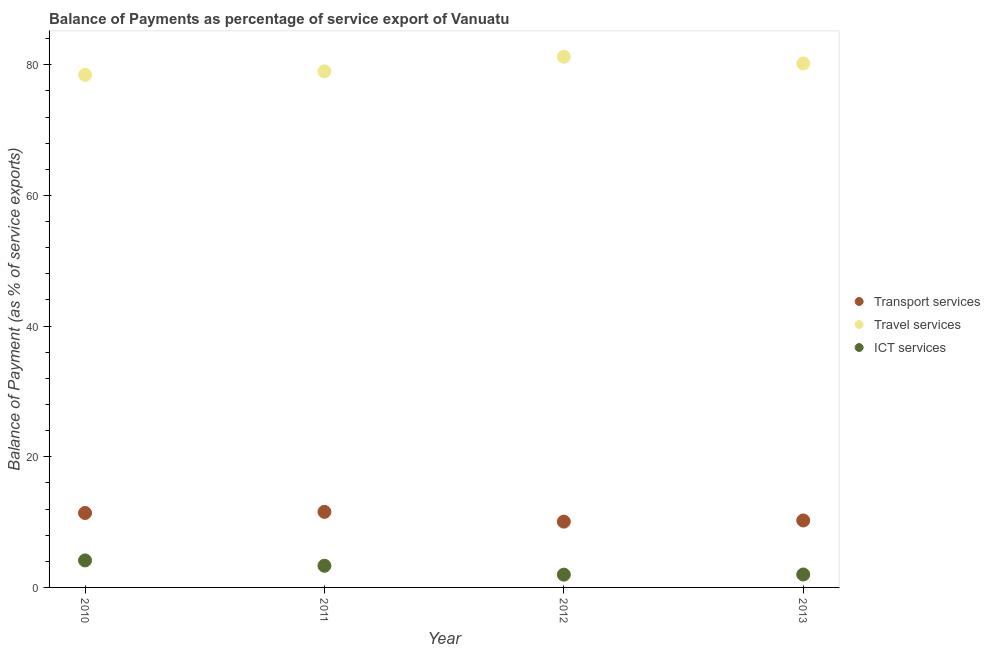Is the number of dotlines equal to the number of legend labels?
Give a very brief answer. Yes. What is the balance of payment of travel services in 2011?
Ensure brevity in your answer.  78.99. Across all years, what is the maximum balance of payment of ict services?
Offer a very short reply. 4.13. Across all years, what is the minimum balance of payment of transport services?
Your answer should be compact. 10.07. In which year was the balance of payment of transport services maximum?
Your answer should be very brief. 2011. What is the total balance of payment of ict services in the graph?
Your response must be concise. 11.38. What is the difference between the balance of payment of travel services in 2011 and that in 2012?
Give a very brief answer. -2.23. What is the difference between the balance of payment of transport services in 2011 and the balance of payment of ict services in 2010?
Offer a very short reply. 7.43. What is the average balance of payment of travel services per year?
Give a very brief answer. 79.72. In the year 2010, what is the difference between the balance of payment of travel services and balance of payment of ict services?
Offer a terse response. 74.32. In how many years, is the balance of payment of transport services greater than 4 %?
Your answer should be very brief. 4. What is the ratio of the balance of payment of travel services in 2010 to that in 2013?
Provide a short and direct response. 0.98. Is the balance of payment of transport services in 2010 less than that in 2011?
Provide a succinct answer. Yes. Is the difference between the balance of payment of travel services in 2011 and 2012 greater than the difference between the balance of payment of ict services in 2011 and 2012?
Provide a succinct answer. No. What is the difference between the highest and the second highest balance of payment of travel services?
Provide a short and direct response. 1.03. What is the difference between the highest and the lowest balance of payment of ict services?
Your answer should be very brief. 2.18. Is the sum of the balance of payment of ict services in 2011 and 2013 greater than the maximum balance of payment of travel services across all years?
Your response must be concise. No. Does the balance of payment of transport services monotonically increase over the years?
Provide a succinct answer. No. Is the balance of payment of transport services strictly greater than the balance of payment of ict services over the years?
Provide a succinct answer. Yes. Is the balance of payment of ict services strictly less than the balance of payment of transport services over the years?
Offer a terse response. Yes. How many dotlines are there?
Offer a very short reply. 3. Are the values on the major ticks of Y-axis written in scientific E-notation?
Offer a terse response. No. How many legend labels are there?
Your response must be concise. 3. How are the legend labels stacked?
Offer a terse response. Vertical. What is the title of the graph?
Your answer should be very brief. Balance of Payments as percentage of service export of Vanuatu. What is the label or title of the Y-axis?
Provide a succinct answer. Balance of Payment (as % of service exports). What is the Balance of Payment (as % of service exports) in Transport services in 2010?
Offer a terse response. 11.4. What is the Balance of Payment (as % of service exports) of Travel services in 2010?
Give a very brief answer. 78.46. What is the Balance of Payment (as % of service exports) in ICT services in 2010?
Keep it short and to the point. 4.13. What is the Balance of Payment (as % of service exports) of Transport services in 2011?
Your answer should be very brief. 11.56. What is the Balance of Payment (as % of service exports) of Travel services in 2011?
Provide a succinct answer. 78.99. What is the Balance of Payment (as % of service exports) of ICT services in 2011?
Offer a terse response. 3.31. What is the Balance of Payment (as % of service exports) of Transport services in 2012?
Give a very brief answer. 10.07. What is the Balance of Payment (as % of service exports) in Travel services in 2012?
Ensure brevity in your answer.  81.23. What is the Balance of Payment (as % of service exports) in ICT services in 2012?
Ensure brevity in your answer.  1.96. What is the Balance of Payment (as % of service exports) in Transport services in 2013?
Offer a very short reply. 10.25. What is the Balance of Payment (as % of service exports) in Travel services in 2013?
Make the answer very short. 80.2. What is the Balance of Payment (as % of service exports) of ICT services in 2013?
Keep it short and to the point. 1.98. Across all years, what is the maximum Balance of Payment (as % of service exports) in Transport services?
Make the answer very short. 11.56. Across all years, what is the maximum Balance of Payment (as % of service exports) in Travel services?
Your answer should be compact. 81.23. Across all years, what is the maximum Balance of Payment (as % of service exports) of ICT services?
Offer a very short reply. 4.13. Across all years, what is the minimum Balance of Payment (as % of service exports) of Transport services?
Offer a terse response. 10.07. Across all years, what is the minimum Balance of Payment (as % of service exports) of Travel services?
Keep it short and to the point. 78.46. Across all years, what is the minimum Balance of Payment (as % of service exports) in ICT services?
Your answer should be compact. 1.96. What is the total Balance of Payment (as % of service exports) of Transport services in the graph?
Your answer should be compact. 43.28. What is the total Balance of Payment (as % of service exports) in Travel services in the graph?
Offer a terse response. 318.88. What is the total Balance of Payment (as % of service exports) of ICT services in the graph?
Provide a succinct answer. 11.38. What is the difference between the Balance of Payment (as % of service exports) of Transport services in 2010 and that in 2011?
Give a very brief answer. -0.17. What is the difference between the Balance of Payment (as % of service exports) of Travel services in 2010 and that in 2011?
Offer a very short reply. -0.54. What is the difference between the Balance of Payment (as % of service exports) in ICT services in 2010 and that in 2011?
Your answer should be compact. 0.82. What is the difference between the Balance of Payment (as % of service exports) in Transport services in 2010 and that in 2012?
Offer a very short reply. 1.33. What is the difference between the Balance of Payment (as % of service exports) in Travel services in 2010 and that in 2012?
Keep it short and to the point. -2.77. What is the difference between the Balance of Payment (as % of service exports) of ICT services in 2010 and that in 2012?
Your answer should be very brief. 2.18. What is the difference between the Balance of Payment (as % of service exports) in Transport services in 2010 and that in 2013?
Ensure brevity in your answer.  1.15. What is the difference between the Balance of Payment (as % of service exports) of Travel services in 2010 and that in 2013?
Make the answer very short. -1.74. What is the difference between the Balance of Payment (as % of service exports) in ICT services in 2010 and that in 2013?
Offer a very short reply. 2.15. What is the difference between the Balance of Payment (as % of service exports) in Transport services in 2011 and that in 2012?
Offer a very short reply. 1.49. What is the difference between the Balance of Payment (as % of service exports) of Travel services in 2011 and that in 2012?
Ensure brevity in your answer.  -2.23. What is the difference between the Balance of Payment (as % of service exports) of ICT services in 2011 and that in 2012?
Offer a very short reply. 1.36. What is the difference between the Balance of Payment (as % of service exports) of Transport services in 2011 and that in 2013?
Offer a very short reply. 1.31. What is the difference between the Balance of Payment (as % of service exports) of Travel services in 2011 and that in 2013?
Provide a short and direct response. -1.2. What is the difference between the Balance of Payment (as % of service exports) of ICT services in 2011 and that in 2013?
Give a very brief answer. 1.33. What is the difference between the Balance of Payment (as % of service exports) of Transport services in 2012 and that in 2013?
Ensure brevity in your answer.  -0.18. What is the difference between the Balance of Payment (as % of service exports) of Travel services in 2012 and that in 2013?
Offer a terse response. 1.03. What is the difference between the Balance of Payment (as % of service exports) in ICT services in 2012 and that in 2013?
Ensure brevity in your answer.  -0.03. What is the difference between the Balance of Payment (as % of service exports) of Transport services in 2010 and the Balance of Payment (as % of service exports) of Travel services in 2011?
Make the answer very short. -67.6. What is the difference between the Balance of Payment (as % of service exports) of Transport services in 2010 and the Balance of Payment (as % of service exports) of ICT services in 2011?
Your answer should be very brief. 8.08. What is the difference between the Balance of Payment (as % of service exports) of Travel services in 2010 and the Balance of Payment (as % of service exports) of ICT services in 2011?
Make the answer very short. 75.14. What is the difference between the Balance of Payment (as % of service exports) of Transport services in 2010 and the Balance of Payment (as % of service exports) of Travel services in 2012?
Provide a succinct answer. -69.83. What is the difference between the Balance of Payment (as % of service exports) in Transport services in 2010 and the Balance of Payment (as % of service exports) in ICT services in 2012?
Keep it short and to the point. 9.44. What is the difference between the Balance of Payment (as % of service exports) of Travel services in 2010 and the Balance of Payment (as % of service exports) of ICT services in 2012?
Offer a very short reply. 76.5. What is the difference between the Balance of Payment (as % of service exports) of Transport services in 2010 and the Balance of Payment (as % of service exports) of Travel services in 2013?
Give a very brief answer. -68.8. What is the difference between the Balance of Payment (as % of service exports) in Transport services in 2010 and the Balance of Payment (as % of service exports) in ICT services in 2013?
Keep it short and to the point. 9.42. What is the difference between the Balance of Payment (as % of service exports) of Travel services in 2010 and the Balance of Payment (as % of service exports) of ICT services in 2013?
Ensure brevity in your answer.  76.48. What is the difference between the Balance of Payment (as % of service exports) in Transport services in 2011 and the Balance of Payment (as % of service exports) in Travel services in 2012?
Keep it short and to the point. -69.66. What is the difference between the Balance of Payment (as % of service exports) in Transport services in 2011 and the Balance of Payment (as % of service exports) in ICT services in 2012?
Offer a terse response. 9.61. What is the difference between the Balance of Payment (as % of service exports) in Travel services in 2011 and the Balance of Payment (as % of service exports) in ICT services in 2012?
Ensure brevity in your answer.  77.04. What is the difference between the Balance of Payment (as % of service exports) in Transport services in 2011 and the Balance of Payment (as % of service exports) in Travel services in 2013?
Provide a short and direct response. -68.63. What is the difference between the Balance of Payment (as % of service exports) of Transport services in 2011 and the Balance of Payment (as % of service exports) of ICT services in 2013?
Ensure brevity in your answer.  9.58. What is the difference between the Balance of Payment (as % of service exports) of Travel services in 2011 and the Balance of Payment (as % of service exports) of ICT services in 2013?
Offer a terse response. 77.01. What is the difference between the Balance of Payment (as % of service exports) in Transport services in 2012 and the Balance of Payment (as % of service exports) in Travel services in 2013?
Offer a very short reply. -70.13. What is the difference between the Balance of Payment (as % of service exports) in Transport services in 2012 and the Balance of Payment (as % of service exports) in ICT services in 2013?
Provide a succinct answer. 8.09. What is the difference between the Balance of Payment (as % of service exports) of Travel services in 2012 and the Balance of Payment (as % of service exports) of ICT services in 2013?
Your answer should be very brief. 79.25. What is the average Balance of Payment (as % of service exports) of Transport services per year?
Your answer should be very brief. 10.82. What is the average Balance of Payment (as % of service exports) in Travel services per year?
Give a very brief answer. 79.72. What is the average Balance of Payment (as % of service exports) of ICT services per year?
Your answer should be very brief. 2.85. In the year 2010, what is the difference between the Balance of Payment (as % of service exports) of Transport services and Balance of Payment (as % of service exports) of Travel services?
Provide a succinct answer. -67.06. In the year 2010, what is the difference between the Balance of Payment (as % of service exports) of Transport services and Balance of Payment (as % of service exports) of ICT services?
Provide a short and direct response. 7.26. In the year 2010, what is the difference between the Balance of Payment (as % of service exports) in Travel services and Balance of Payment (as % of service exports) in ICT services?
Provide a succinct answer. 74.32. In the year 2011, what is the difference between the Balance of Payment (as % of service exports) of Transport services and Balance of Payment (as % of service exports) of Travel services?
Give a very brief answer. -67.43. In the year 2011, what is the difference between the Balance of Payment (as % of service exports) in Transport services and Balance of Payment (as % of service exports) in ICT services?
Your answer should be compact. 8.25. In the year 2011, what is the difference between the Balance of Payment (as % of service exports) in Travel services and Balance of Payment (as % of service exports) in ICT services?
Make the answer very short. 75.68. In the year 2012, what is the difference between the Balance of Payment (as % of service exports) of Transport services and Balance of Payment (as % of service exports) of Travel services?
Keep it short and to the point. -71.16. In the year 2012, what is the difference between the Balance of Payment (as % of service exports) in Transport services and Balance of Payment (as % of service exports) in ICT services?
Your answer should be compact. 8.11. In the year 2012, what is the difference between the Balance of Payment (as % of service exports) in Travel services and Balance of Payment (as % of service exports) in ICT services?
Keep it short and to the point. 79.27. In the year 2013, what is the difference between the Balance of Payment (as % of service exports) of Transport services and Balance of Payment (as % of service exports) of Travel services?
Your answer should be compact. -69.95. In the year 2013, what is the difference between the Balance of Payment (as % of service exports) of Transport services and Balance of Payment (as % of service exports) of ICT services?
Make the answer very short. 8.27. In the year 2013, what is the difference between the Balance of Payment (as % of service exports) in Travel services and Balance of Payment (as % of service exports) in ICT services?
Make the answer very short. 78.21. What is the ratio of the Balance of Payment (as % of service exports) of Transport services in 2010 to that in 2011?
Give a very brief answer. 0.99. What is the ratio of the Balance of Payment (as % of service exports) of Travel services in 2010 to that in 2011?
Your answer should be very brief. 0.99. What is the ratio of the Balance of Payment (as % of service exports) of ICT services in 2010 to that in 2011?
Your response must be concise. 1.25. What is the ratio of the Balance of Payment (as % of service exports) of Transport services in 2010 to that in 2012?
Your response must be concise. 1.13. What is the ratio of the Balance of Payment (as % of service exports) of Travel services in 2010 to that in 2012?
Make the answer very short. 0.97. What is the ratio of the Balance of Payment (as % of service exports) of ICT services in 2010 to that in 2012?
Your response must be concise. 2.11. What is the ratio of the Balance of Payment (as % of service exports) in Transport services in 2010 to that in 2013?
Keep it short and to the point. 1.11. What is the ratio of the Balance of Payment (as % of service exports) in Travel services in 2010 to that in 2013?
Your answer should be very brief. 0.98. What is the ratio of the Balance of Payment (as % of service exports) in ICT services in 2010 to that in 2013?
Give a very brief answer. 2.09. What is the ratio of the Balance of Payment (as % of service exports) in Transport services in 2011 to that in 2012?
Provide a short and direct response. 1.15. What is the ratio of the Balance of Payment (as % of service exports) in Travel services in 2011 to that in 2012?
Keep it short and to the point. 0.97. What is the ratio of the Balance of Payment (as % of service exports) in ICT services in 2011 to that in 2012?
Keep it short and to the point. 1.7. What is the ratio of the Balance of Payment (as % of service exports) of Transport services in 2011 to that in 2013?
Offer a terse response. 1.13. What is the ratio of the Balance of Payment (as % of service exports) of Travel services in 2011 to that in 2013?
Provide a succinct answer. 0.98. What is the ratio of the Balance of Payment (as % of service exports) in ICT services in 2011 to that in 2013?
Provide a succinct answer. 1.67. What is the ratio of the Balance of Payment (as % of service exports) of Transport services in 2012 to that in 2013?
Your response must be concise. 0.98. What is the ratio of the Balance of Payment (as % of service exports) in Travel services in 2012 to that in 2013?
Offer a very short reply. 1.01. What is the ratio of the Balance of Payment (as % of service exports) in ICT services in 2012 to that in 2013?
Your answer should be compact. 0.99. What is the difference between the highest and the second highest Balance of Payment (as % of service exports) in Transport services?
Provide a short and direct response. 0.17. What is the difference between the highest and the second highest Balance of Payment (as % of service exports) in Travel services?
Your answer should be compact. 1.03. What is the difference between the highest and the second highest Balance of Payment (as % of service exports) in ICT services?
Give a very brief answer. 0.82. What is the difference between the highest and the lowest Balance of Payment (as % of service exports) in Transport services?
Your response must be concise. 1.49. What is the difference between the highest and the lowest Balance of Payment (as % of service exports) of Travel services?
Ensure brevity in your answer.  2.77. What is the difference between the highest and the lowest Balance of Payment (as % of service exports) in ICT services?
Your answer should be very brief. 2.18. 